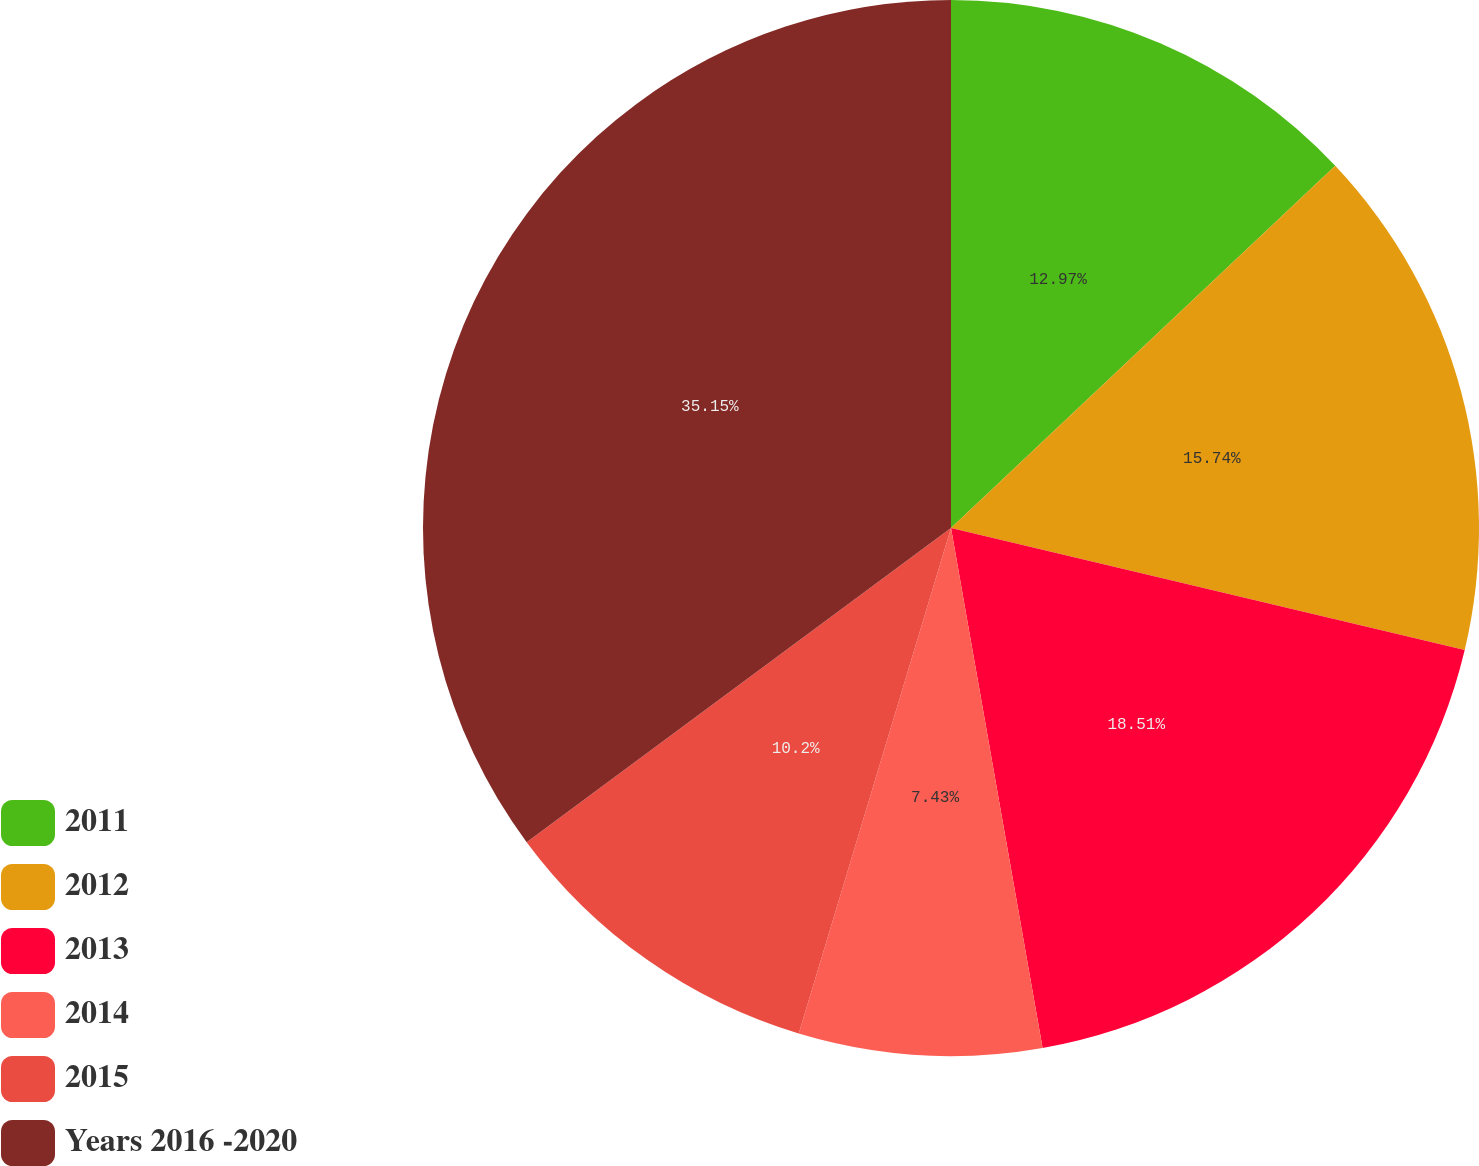Convert chart. <chart><loc_0><loc_0><loc_500><loc_500><pie_chart><fcel>2011<fcel>2012<fcel>2013<fcel>2014<fcel>2015<fcel>Years 2016 -2020<nl><fcel>12.97%<fcel>15.74%<fcel>18.51%<fcel>7.43%<fcel>10.2%<fcel>35.14%<nl></chart> 